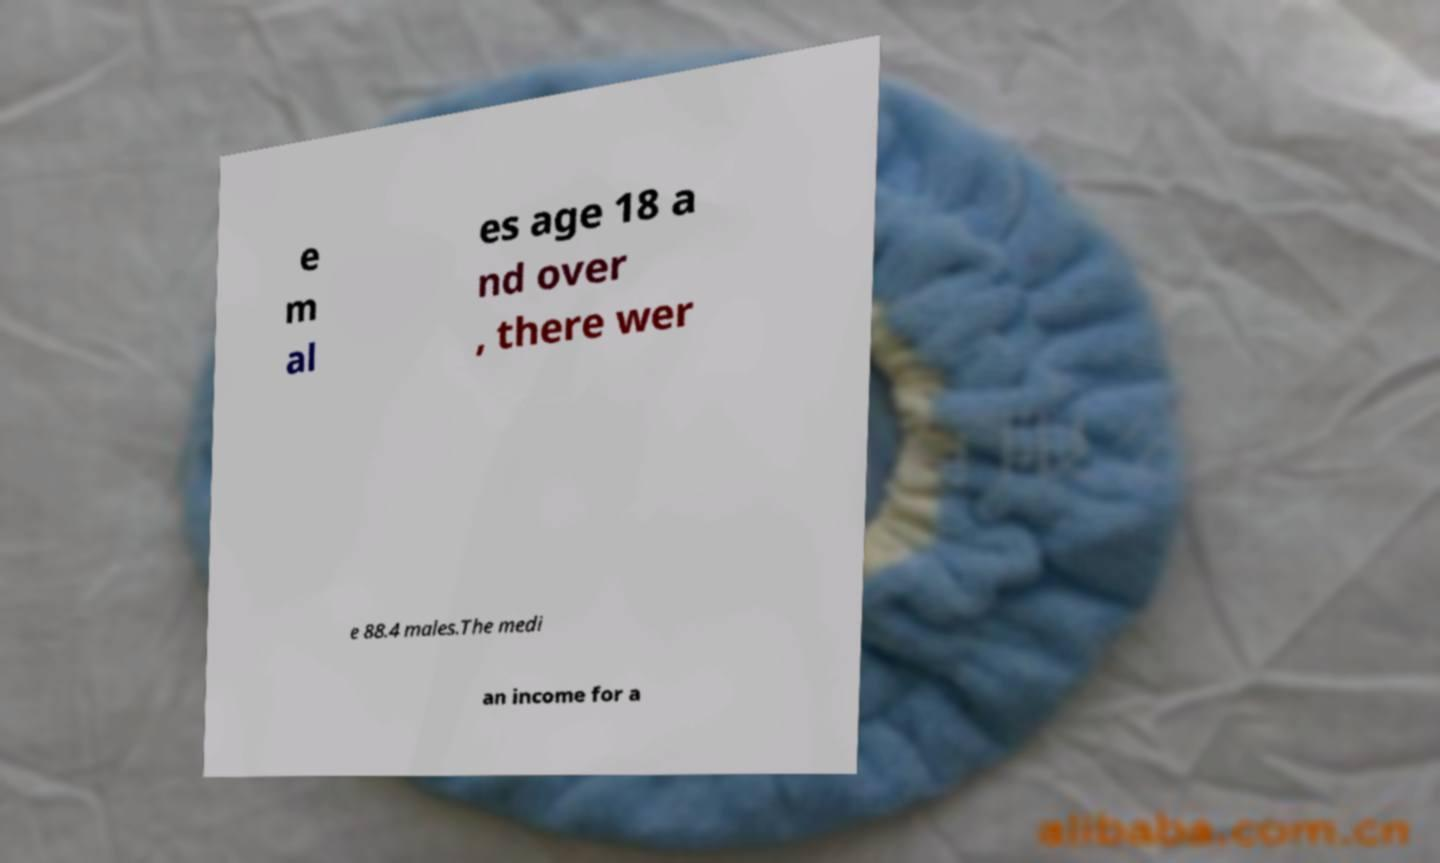Please identify and transcribe the text found in this image. e m al es age 18 a nd over , there wer e 88.4 males.The medi an income for a 